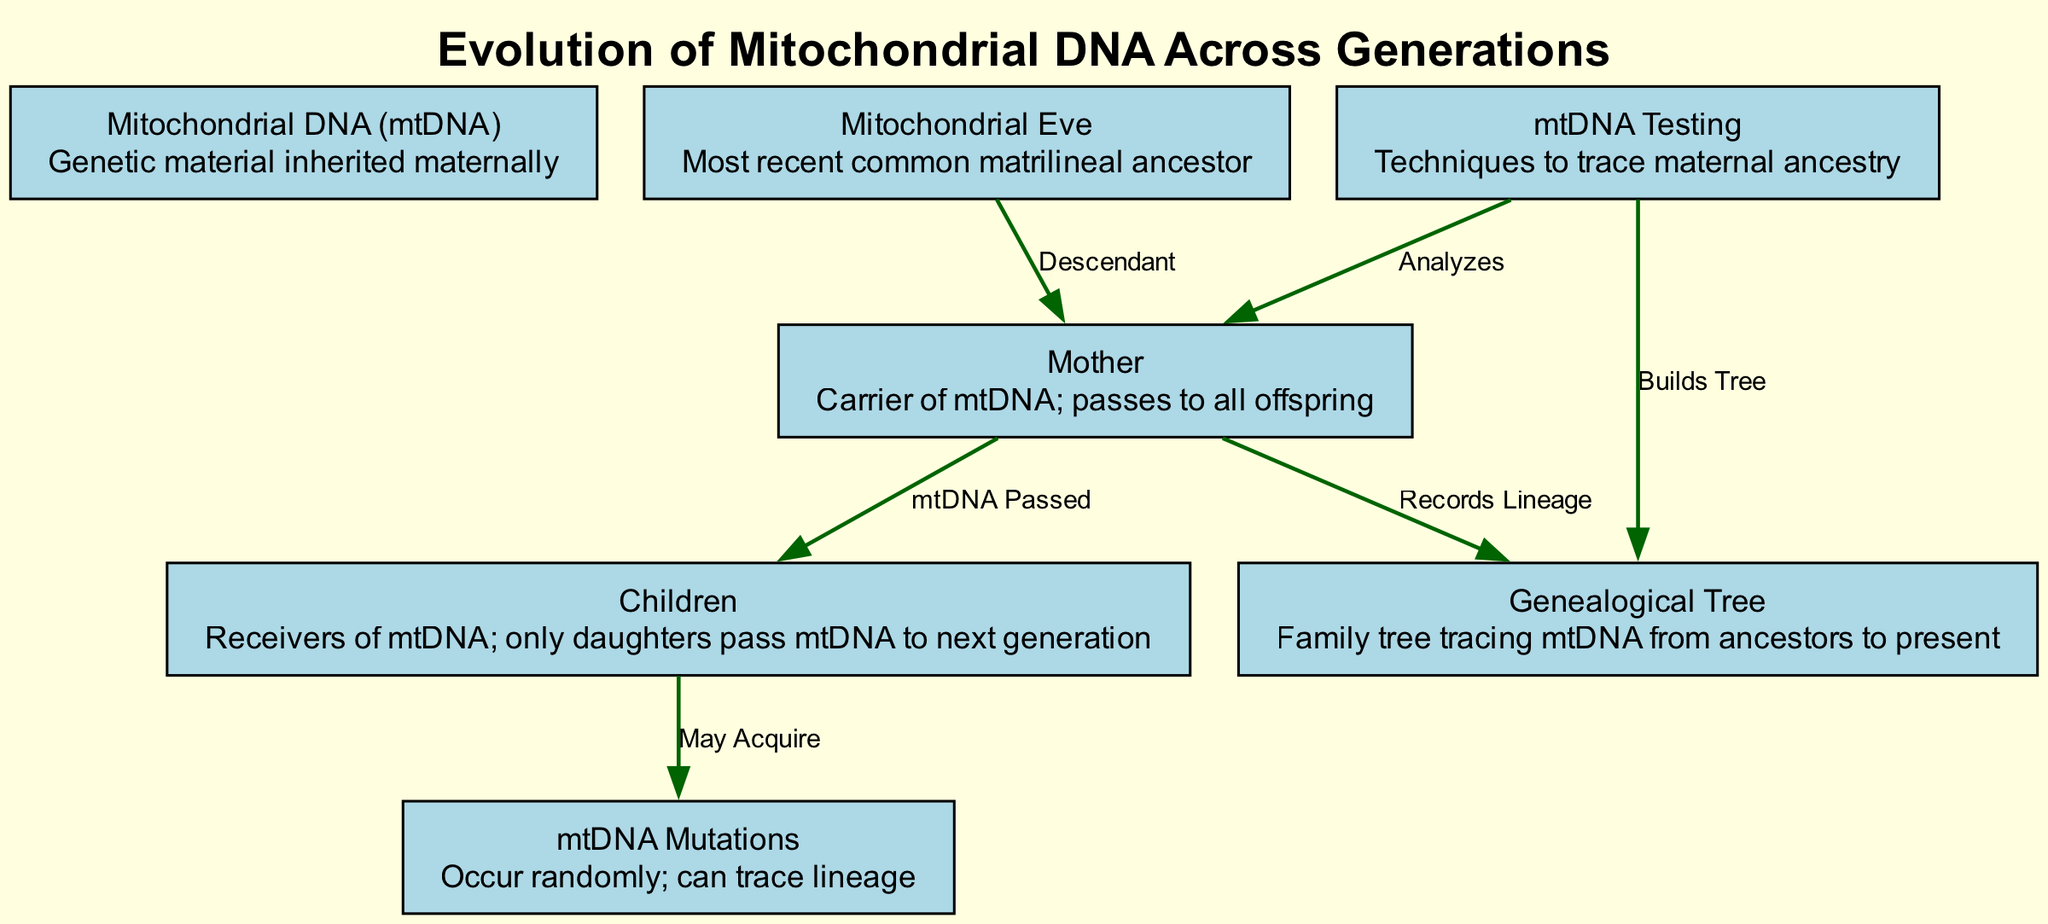What is the title of the diagram? The title of the diagram is explicitly provided in the data as "Evolution of Mitochondrial DNA Across Generations".
Answer: Evolution of Mitochondrial DNA Across Generations How many nodes are in the diagram? By counting the nodes listed in the data, there are 7 nodes present: mtDNA, Mitochondrial Eve, Mother, Children, mtDNA Mutations, Genealogical Tree, and mtDNA Testing.
Answer: 7 What is the relationship between Mitochondrial Eve and Mother? The relationship is labeled as "Descendant", indicating that the Mother is a descendant of Mitochondrial Eve in the lineage.
Answer: Descendant Which node records lineage? The node that records lineage is labeled "Genealogy" and is directly associated with the Mother node in the diagram.
Answer: Genealogy What do Children acquire from their Mother? Children may acquire mtDNA from their Mother, as indicated in the edge labeled "mtDNA Passed".
Answer: mtDNA What can mtDNA Testing do according to the diagram? mtDNA Testing can analyze the Mother and also builds a genealogical tree, both of which are indicated by the edges coming from the Testing node.
Answer: Analyzes and Builds Tree What happens to mtDNA in Children? Children may acquire mutations as indicated by the connection between the Children node and the Mutations node, showing a potential for changes over generations.
Answer: May Acquire How does the Mother relate to the mtDNA Genealogical Tree? The Mother is directly connected to the Genealogical Tree node through the edge labeled "Records Lineage", showing that the Mother contributes to the genealogical record.
Answer: Records Lineage How many unique relationships are shown in the diagram? By counting the edges in the data, there are 6 unique relationships depicted between the nodes.
Answer: 6 